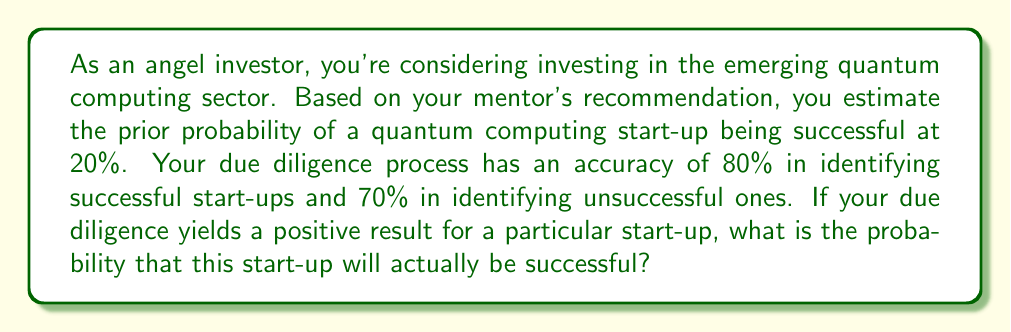Help me with this question. Let's approach this problem using Bayes' Theorem:

1) Define events:
   S: Start-up is successful
   P: Positive due diligence result

2) Given information:
   P(S) = 0.20 (prior probability of success)
   P(P|S) = 0.80 (true positive rate)
   P(P|not S) = 0.30 (false positive rate)

3) Bayes' Theorem:
   $$P(S|P) = \frac{P(P|S) \cdot P(S)}{P(P)}$$

4) Calculate P(P):
   P(P) = P(P|S) · P(S) + P(P|not S) · P(not S)
   P(P) = 0.80 · 0.20 + 0.30 · 0.80 = 0.16 + 0.24 = 0.40

5) Apply Bayes' Theorem:
   $$P(S|P) = \frac{0.80 \cdot 0.20}{0.40} = \frac{0.16}{0.40} = 0.40$$

6) Convert to percentage:
   0.40 · 100% = 40%
Answer: 40% 